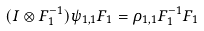<formula> <loc_0><loc_0><loc_500><loc_500>( I \otimes F _ { 1 } ^ { - 1 } ) \psi _ { 1 , 1 } F _ { 1 } = \rho _ { 1 , 1 } F _ { 1 } ^ { - 1 } F _ { 1 }</formula> 